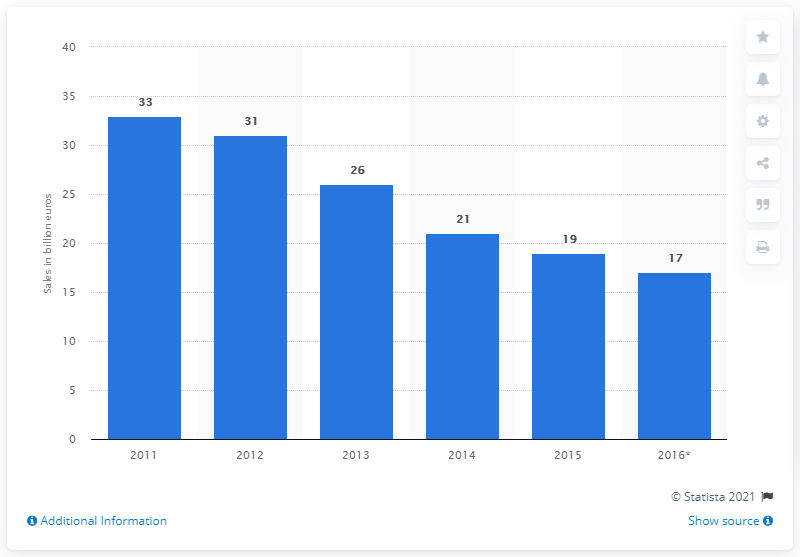Give some essential details in this illustration. In 2015, the digital camera market was approximately 19... 